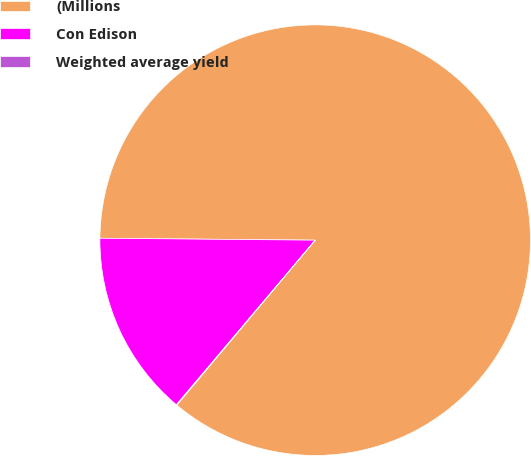Convert chart to OTSL. <chart><loc_0><loc_0><loc_500><loc_500><pie_chart><fcel>(Millions<fcel>Con Edison<fcel>Weighted average yield<nl><fcel>85.96%<fcel>13.99%<fcel>0.05%<nl></chart> 